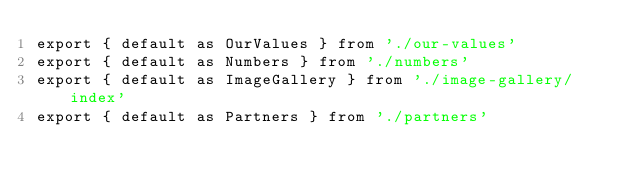<code> <loc_0><loc_0><loc_500><loc_500><_TypeScript_>export { default as OurValues } from './our-values'
export { default as Numbers } from './numbers'
export { default as ImageGallery } from './image-gallery/index'
export { default as Partners } from './partners'
</code> 